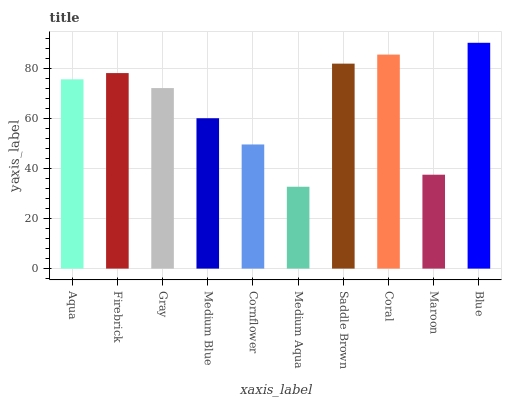Is Medium Aqua the minimum?
Answer yes or no. Yes. Is Blue the maximum?
Answer yes or no. Yes. Is Firebrick the minimum?
Answer yes or no. No. Is Firebrick the maximum?
Answer yes or no. No. Is Firebrick greater than Aqua?
Answer yes or no. Yes. Is Aqua less than Firebrick?
Answer yes or no. Yes. Is Aqua greater than Firebrick?
Answer yes or no. No. Is Firebrick less than Aqua?
Answer yes or no. No. Is Aqua the high median?
Answer yes or no. Yes. Is Gray the low median?
Answer yes or no. Yes. Is Maroon the high median?
Answer yes or no. No. Is Firebrick the low median?
Answer yes or no. No. 